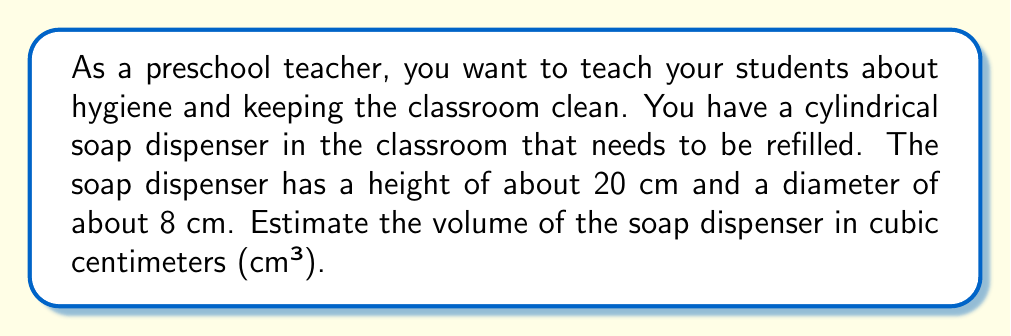Provide a solution to this math problem. To estimate the volume of a cylindrical soap dispenser, we need to use the formula for the volume of a cylinder:

$$V = \pi r^2 h$$

Where:
$V$ = volume
$\pi$ ≈ 3.14 (we'll use this approximation)
$r$ = radius (half of the diameter)
$h$ = height

Let's follow these steps:

1. Calculate the radius:
   The diameter is 8 cm, so the radius is half of that.
   $r = 8 \div 2 = 4$ cm

2. Square the radius:
   $r^2 = 4^2 = 16$ cm²

3. Multiply by π (3.14):
   $\pi r^2 = 3.14 \times 16 = 50.24$ cm²

4. Multiply by the height:
   $V = \pi r^2 h = 50.24 \times 20 = 1004.8$ cm³

5. Round to a reasonable estimate:
   We can round 1004.8 cm³ to 1000 cm³ for a good estimate.
Answer: The estimated volume of the cylindrical soap dispenser is approximately 1000 cm³. 